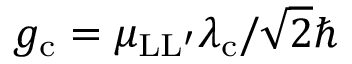<formula> <loc_0><loc_0><loc_500><loc_500>g _ { c } = \mu _ { L L ^ { \prime } } \lambda _ { c } / \sqrt { 2 } \hbar</formula> 